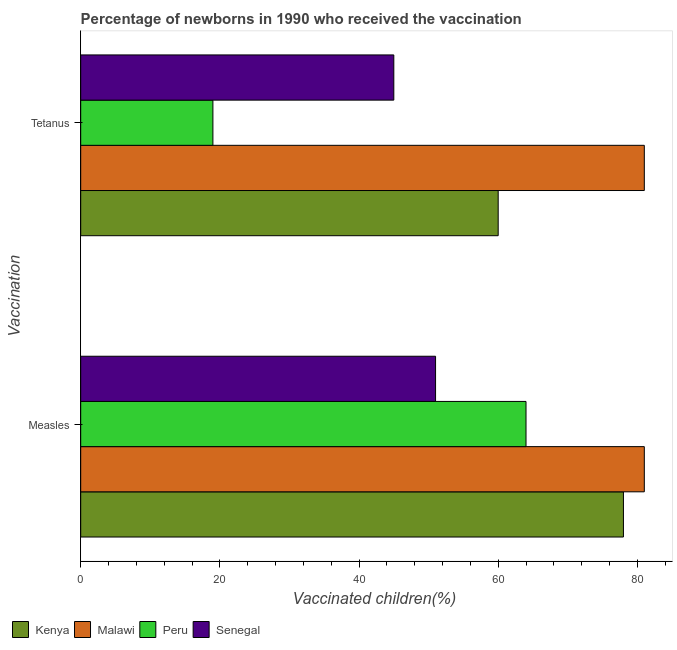How many different coloured bars are there?
Keep it short and to the point. 4. How many groups of bars are there?
Give a very brief answer. 2. Are the number of bars per tick equal to the number of legend labels?
Offer a very short reply. Yes. Are the number of bars on each tick of the Y-axis equal?
Your answer should be compact. Yes. How many bars are there on the 2nd tick from the top?
Give a very brief answer. 4. How many bars are there on the 1st tick from the bottom?
Ensure brevity in your answer.  4. What is the label of the 2nd group of bars from the top?
Your answer should be compact. Measles. What is the percentage of newborns who received vaccination for measles in Kenya?
Offer a terse response. 78. Across all countries, what is the maximum percentage of newborns who received vaccination for tetanus?
Give a very brief answer. 81. Across all countries, what is the minimum percentage of newborns who received vaccination for measles?
Give a very brief answer. 51. In which country was the percentage of newborns who received vaccination for tetanus maximum?
Give a very brief answer. Malawi. In which country was the percentage of newborns who received vaccination for measles minimum?
Provide a succinct answer. Senegal. What is the total percentage of newborns who received vaccination for measles in the graph?
Your response must be concise. 274. What is the difference between the percentage of newborns who received vaccination for measles in Senegal and that in Kenya?
Offer a very short reply. -27. What is the difference between the percentage of newborns who received vaccination for tetanus in Kenya and the percentage of newborns who received vaccination for measles in Peru?
Keep it short and to the point. -4. What is the average percentage of newborns who received vaccination for tetanus per country?
Keep it short and to the point. 51.25. What is the ratio of the percentage of newborns who received vaccination for tetanus in Senegal to that in Malawi?
Keep it short and to the point. 0.56. What does the 4th bar from the top in Tetanus represents?
Your answer should be compact. Kenya. Are all the bars in the graph horizontal?
Offer a very short reply. Yes. What is the difference between two consecutive major ticks on the X-axis?
Your answer should be very brief. 20. Where does the legend appear in the graph?
Provide a succinct answer. Bottom left. How many legend labels are there?
Give a very brief answer. 4. What is the title of the graph?
Keep it short and to the point. Percentage of newborns in 1990 who received the vaccination. What is the label or title of the X-axis?
Make the answer very short. Vaccinated children(%)
. What is the label or title of the Y-axis?
Provide a succinct answer. Vaccination. What is the Vaccinated children(%)
 in Kenya in Measles?
Keep it short and to the point. 78. What is the Vaccinated children(%)
 in Peru in Measles?
Provide a short and direct response. 64. What is the Vaccinated children(%)
 of Kenya in Tetanus?
Provide a short and direct response. 60. What is the Vaccinated children(%)
 of Malawi in Tetanus?
Offer a very short reply. 81. Across all Vaccination, what is the maximum Vaccinated children(%)
 in Kenya?
Your answer should be compact. 78. Across all Vaccination, what is the maximum Vaccinated children(%)
 of Malawi?
Ensure brevity in your answer.  81. Across all Vaccination, what is the maximum Vaccinated children(%)
 of Peru?
Keep it short and to the point. 64. Across all Vaccination, what is the minimum Vaccinated children(%)
 of Malawi?
Provide a short and direct response. 81. Across all Vaccination, what is the minimum Vaccinated children(%)
 in Senegal?
Offer a very short reply. 45. What is the total Vaccinated children(%)
 of Kenya in the graph?
Keep it short and to the point. 138. What is the total Vaccinated children(%)
 in Malawi in the graph?
Your answer should be compact. 162. What is the total Vaccinated children(%)
 in Peru in the graph?
Offer a very short reply. 83. What is the total Vaccinated children(%)
 of Senegal in the graph?
Provide a succinct answer. 96. What is the difference between the Vaccinated children(%)
 of Malawi in Measles and that in Tetanus?
Your response must be concise. 0. What is the difference between the Vaccinated children(%)
 of Senegal in Measles and that in Tetanus?
Keep it short and to the point. 6. What is the difference between the Vaccinated children(%)
 of Kenya in Measles and the Vaccinated children(%)
 of Malawi in Tetanus?
Your answer should be compact. -3. What is the difference between the Vaccinated children(%)
 in Malawi in Measles and the Vaccinated children(%)
 in Peru in Tetanus?
Give a very brief answer. 62. What is the difference between the Vaccinated children(%)
 of Peru in Measles and the Vaccinated children(%)
 of Senegal in Tetanus?
Provide a succinct answer. 19. What is the average Vaccinated children(%)
 in Kenya per Vaccination?
Make the answer very short. 69. What is the average Vaccinated children(%)
 of Malawi per Vaccination?
Offer a terse response. 81. What is the average Vaccinated children(%)
 in Peru per Vaccination?
Keep it short and to the point. 41.5. What is the average Vaccinated children(%)
 in Senegal per Vaccination?
Provide a short and direct response. 48. What is the difference between the Vaccinated children(%)
 of Kenya and Vaccinated children(%)
 of Malawi in Measles?
Keep it short and to the point. -3. What is the difference between the Vaccinated children(%)
 of Kenya and Vaccinated children(%)
 of Senegal in Measles?
Offer a terse response. 27. What is the difference between the Vaccinated children(%)
 of Malawi and Vaccinated children(%)
 of Senegal in Measles?
Give a very brief answer. 30. What is the difference between the Vaccinated children(%)
 in Peru and Vaccinated children(%)
 in Senegal in Measles?
Offer a terse response. 13. What is the difference between the Vaccinated children(%)
 of Kenya and Vaccinated children(%)
 of Malawi in Tetanus?
Your answer should be very brief. -21. What is the difference between the Vaccinated children(%)
 in Malawi and Vaccinated children(%)
 in Senegal in Tetanus?
Provide a succinct answer. 36. What is the difference between the Vaccinated children(%)
 of Peru and Vaccinated children(%)
 of Senegal in Tetanus?
Give a very brief answer. -26. What is the ratio of the Vaccinated children(%)
 of Kenya in Measles to that in Tetanus?
Your answer should be very brief. 1.3. What is the ratio of the Vaccinated children(%)
 of Malawi in Measles to that in Tetanus?
Make the answer very short. 1. What is the ratio of the Vaccinated children(%)
 of Peru in Measles to that in Tetanus?
Provide a short and direct response. 3.37. What is the ratio of the Vaccinated children(%)
 of Senegal in Measles to that in Tetanus?
Your answer should be very brief. 1.13. What is the difference between the highest and the second highest Vaccinated children(%)
 of Kenya?
Offer a terse response. 18. What is the difference between the highest and the lowest Vaccinated children(%)
 in Kenya?
Ensure brevity in your answer.  18. What is the difference between the highest and the lowest Vaccinated children(%)
 in Peru?
Offer a terse response. 45. 